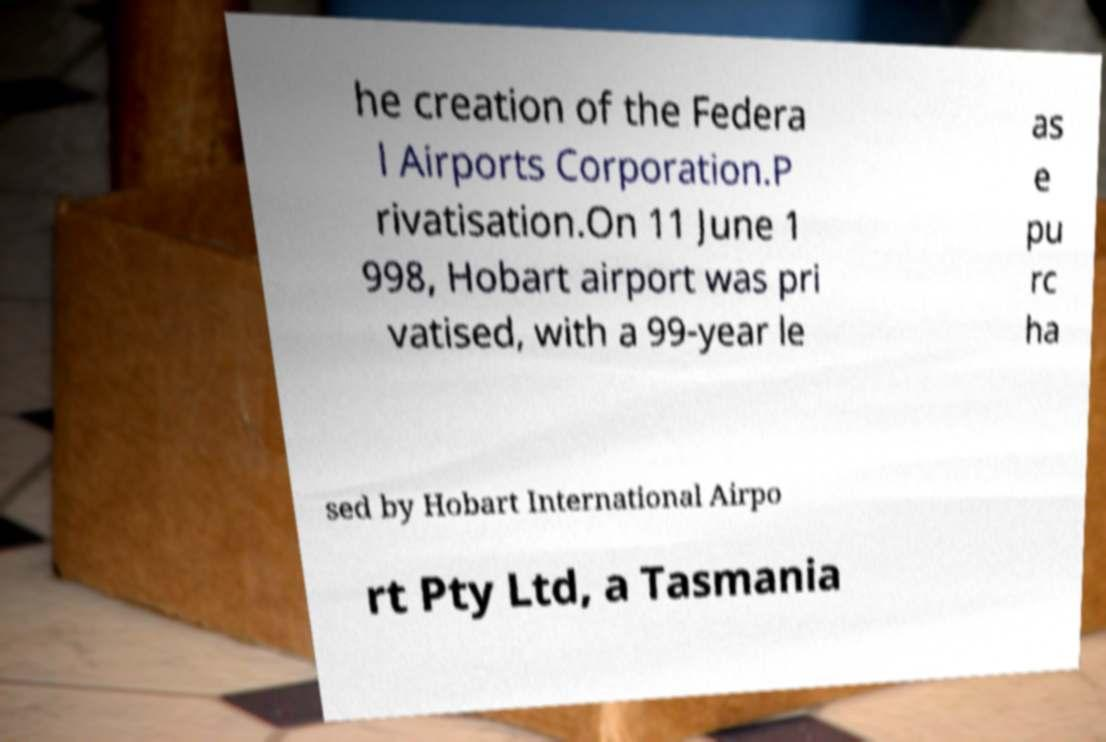What messages or text are displayed in this image? I need them in a readable, typed format. he creation of the Federa l Airports Corporation.P rivatisation.On 11 June 1 998, Hobart airport was pri vatised, with a 99-year le as e pu rc ha sed by Hobart International Airpo rt Pty Ltd, a Tasmania 